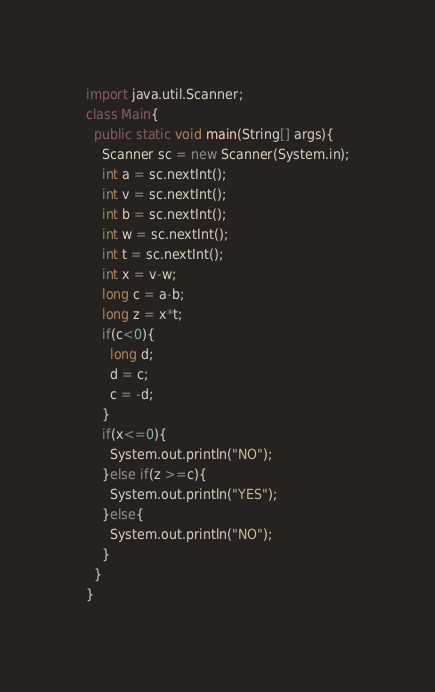Convert code to text. <code><loc_0><loc_0><loc_500><loc_500><_Java_>import java.util.Scanner;
class Main{
  public static void main(String[] args){
    Scanner sc = new Scanner(System.in);
    int a = sc.nextInt();
    int v = sc.nextInt();
    int b = sc.nextInt();
    int w = sc.nextInt();
    int t = sc.nextInt();
    int x = v-w;
    long c = a-b;
    long z = x*t;
    if(c<0){
      long d;
      d = c;
      c = -d;
    }
    if(x<=0){
      System.out.println("NO");
    }else if(z >=c){
      System.out.println("YES");
    }else{
      System.out.println("NO");
    }
  }
}</code> 